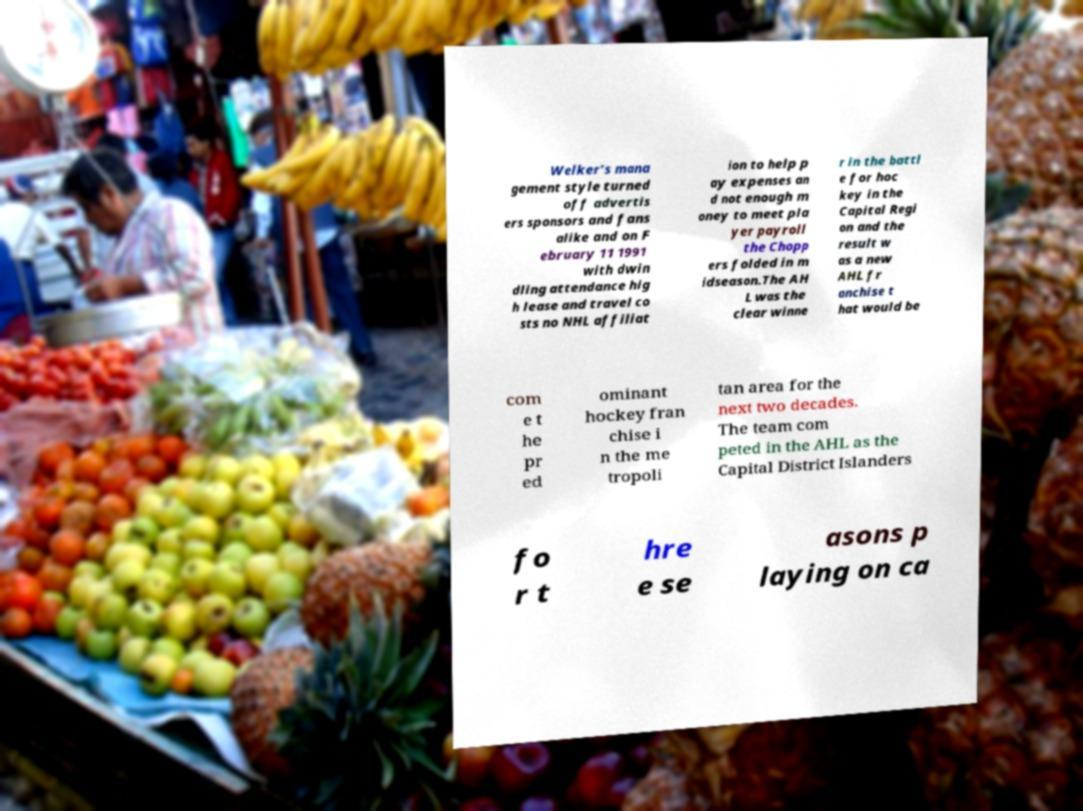Please identify and transcribe the text found in this image. Welker's mana gement style turned off advertis ers sponsors and fans alike and on F ebruary 11 1991 with dwin dling attendance hig h lease and travel co sts no NHL affiliat ion to help p ay expenses an d not enough m oney to meet pla yer payroll the Chopp ers folded in m idseason.The AH L was the clear winne r in the battl e for hoc key in the Capital Regi on and the result w as a new AHL fr anchise t hat would be com e t he pr ed ominant hockey fran chise i n the me tropoli tan area for the next two decades. The team com peted in the AHL as the Capital District Islanders fo r t hre e se asons p laying on ca 